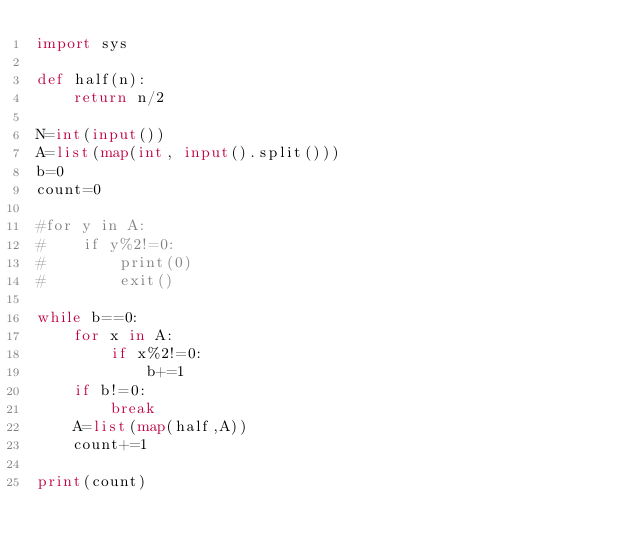<code> <loc_0><loc_0><loc_500><loc_500><_Python_>import sys

def half(n):
    return n/2

N=int(input())
A=list(map(int, input().split()))
b=0
count=0

#for y in A:
#    if y%2!=0:
#        print(0)
#        exit()

while b==0:
    for x in A:
        if x%2!=0:
            b+=1
    if b!=0:
        break
    A=list(map(half,A))
    count+=1
    
print(count)</code> 